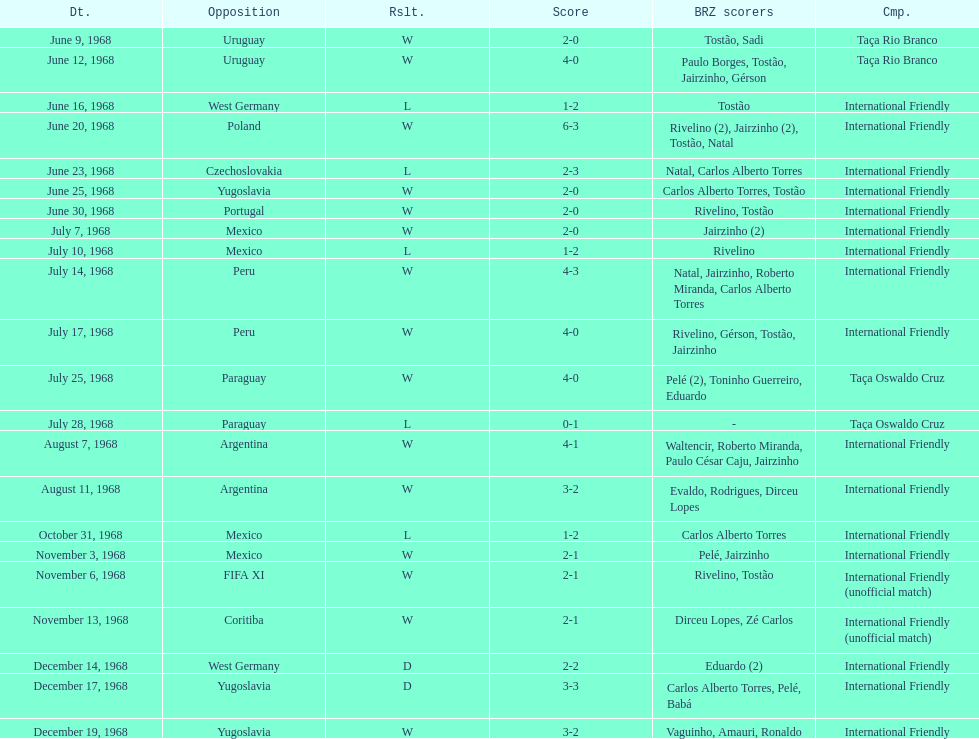How many times did brazil play against argentina in the international friendly competition? 2. 